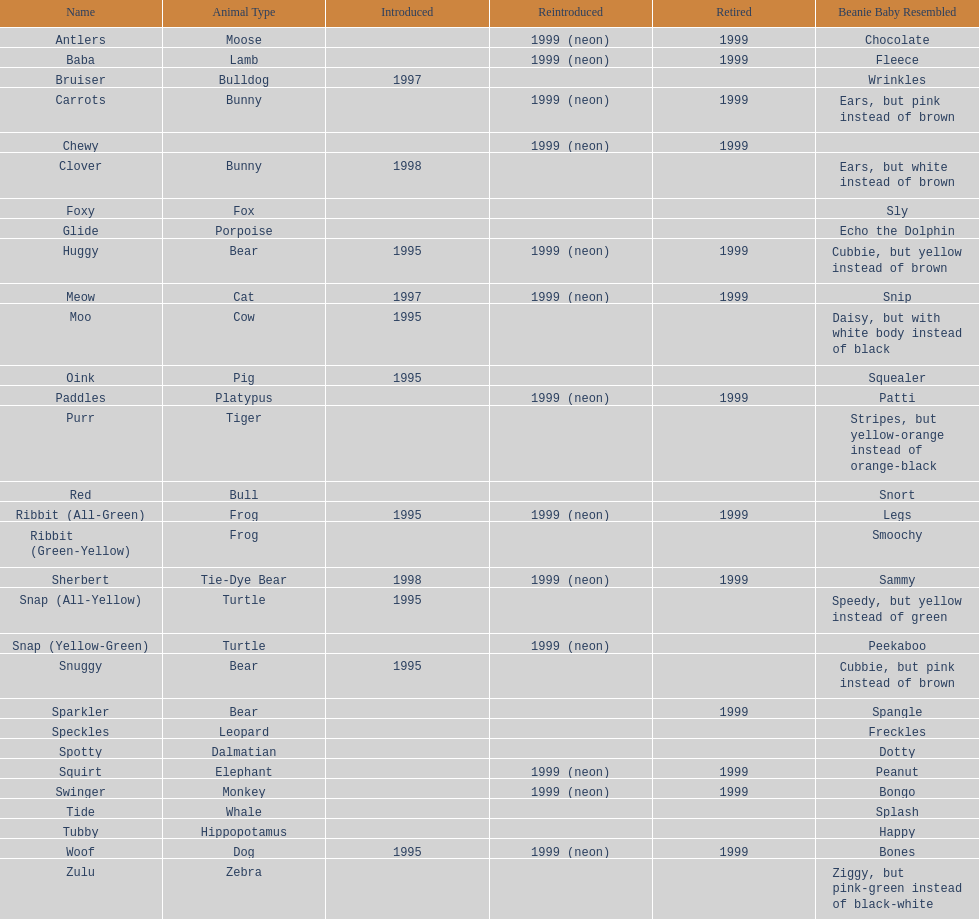What is the count of monkey pillow pals? 1. Parse the table in full. {'header': ['Name', 'Animal Type', 'Introduced', 'Reintroduced', 'Retired', 'Beanie Baby Resembled'], 'rows': [['Antlers', 'Moose', '', '1999 (neon)', '1999', 'Chocolate'], ['Baba', 'Lamb', '', '1999 (neon)', '1999', 'Fleece'], ['Bruiser', 'Bulldog', '1997', '', '', 'Wrinkles'], ['Carrots', 'Bunny', '', '1999 (neon)', '1999', 'Ears, but pink instead of brown'], ['Chewy', '', '', '1999 (neon)', '1999', ''], ['Clover', 'Bunny', '1998', '', '', 'Ears, but white instead of brown'], ['Foxy', 'Fox', '', '', '', 'Sly'], ['Glide', 'Porpoise', '', '', '', 'Echo the Dolphin'], ['Huggy', 'Bear', '1995', '1999 (neon)', '1999', 'Cubbie, but yellow instead of brown'], ['Meow', 'Cat', '1997', '1999 (neon)', '1999', 'Snip'], ['Moo', 'Cow', '1995', '', '', 'Daisy, but with white body instead of black'], ['Oink', 'Pig', '1995', '', '', 'Squealer'], ['Paddles', 'Platypus', '', '1999 (neon)', '1999', 'Patti'], ['Purr', 'Tiger', '', '', '', 'Stripes, but yellow-orange instead of orange-black'], ['Red', 'Bull', '', '', '', 'Snort'], ['Ribbit (All-Green)', 'Frog', '1995', '1999 (neon)', '1999', 'Legs'], ['Ribbit (Green-Yellow)', 'Frog', '', '', '', 'Smoochy'], ['Sherbert', 'Tie-Dye Bear', '1998', '1999 (neon)', '1999', 'Sammy'], ['Snap (All-Yellow)', 'Turtle', '1995', '', '', 'Speedy, but yellow instead of green'], ['Snap (Yellow-Green)', 'Turtle', '', '1999 (neon)', '', 'Peekaboo'], ['Snuggy', 'Bear', '1995', '', '', 'Cubbie, but pink instead of brown'], ['Sparkler', 'Bear', '', '', '1999', 'Spangle'], ['Speckles', 'Leopard', '', '', '', 'Freckles'], ['Spotty', 'Dalmatian', '', '', '', 'Dotty'], ['Squirt', 'Elephant', '', '1999 (neon)', '1999', 'Peanut'], ['Swinger', 'Monkey', '', '1999 (neon)', '1999', 'Bongo'], ['Tide', 'Whale', '', '', '', 'Splash'], ['Tubby', 'Hippopotamus', '', '', '', 'Happy'], ['Woof', 'Dog', '1995', '1999 (neon)', '1999', 'Bones'], ['Zulu', 'Zebra', '', '', '', 'Ziggy, but pink-green instead of black-white']]} 